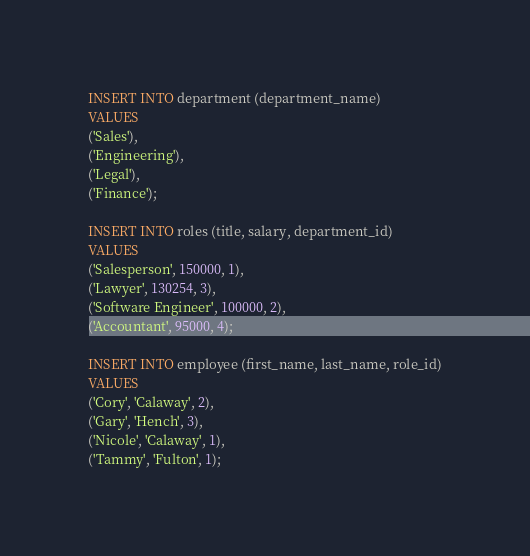Convert code to text. <code><loc_0><loc_0><loc_500><loc_500><_SQL_>INSERT INTO department (department_name)
VALUES 
('Sales'),
('Engineering'),
('Legal'),
('Finance');

INSERT INTO roles (title, salary, department_id)
VALUES 
('Salesperson', 150000, 1),
('Lawyer', 130254, 3),
('Software Engineer', 100000, 2),
('Accountant', 95000, 4);

INSERT INTO employee (first_name, last_name, role_id)
VALUES 
('Cory', 'Calaway', 2),
('Gary', 'Hench', 3),
('Nicole', 'Calaway', 1),
('Tammy', 'Fulton', 1);



</code> 